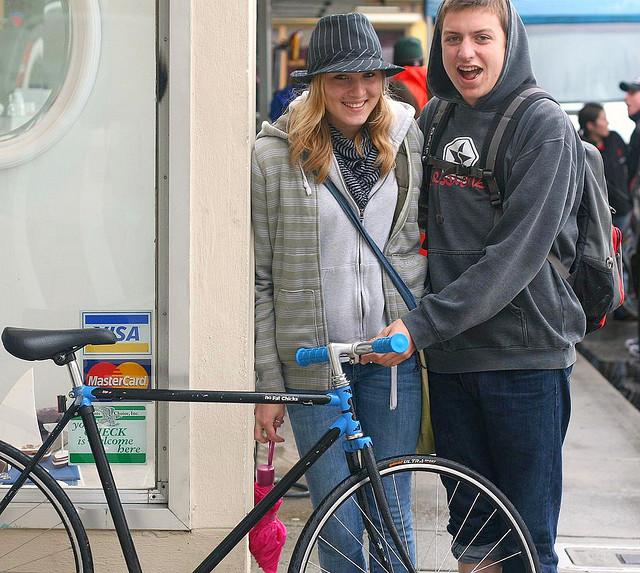What color is the girl's hat?
Answer briefly. Black and white. How many bikes are in the photo?
Short answer required. 1. What form of transportation did the couple use?
Answer briefly. Bicycle. Is this a competition?
Quick response, please. No. Do they accept American express?
Quick response, please. No. What time of day is it?
Be succinct. Morning. Is this the start of a race?
Keep it brief. No. 